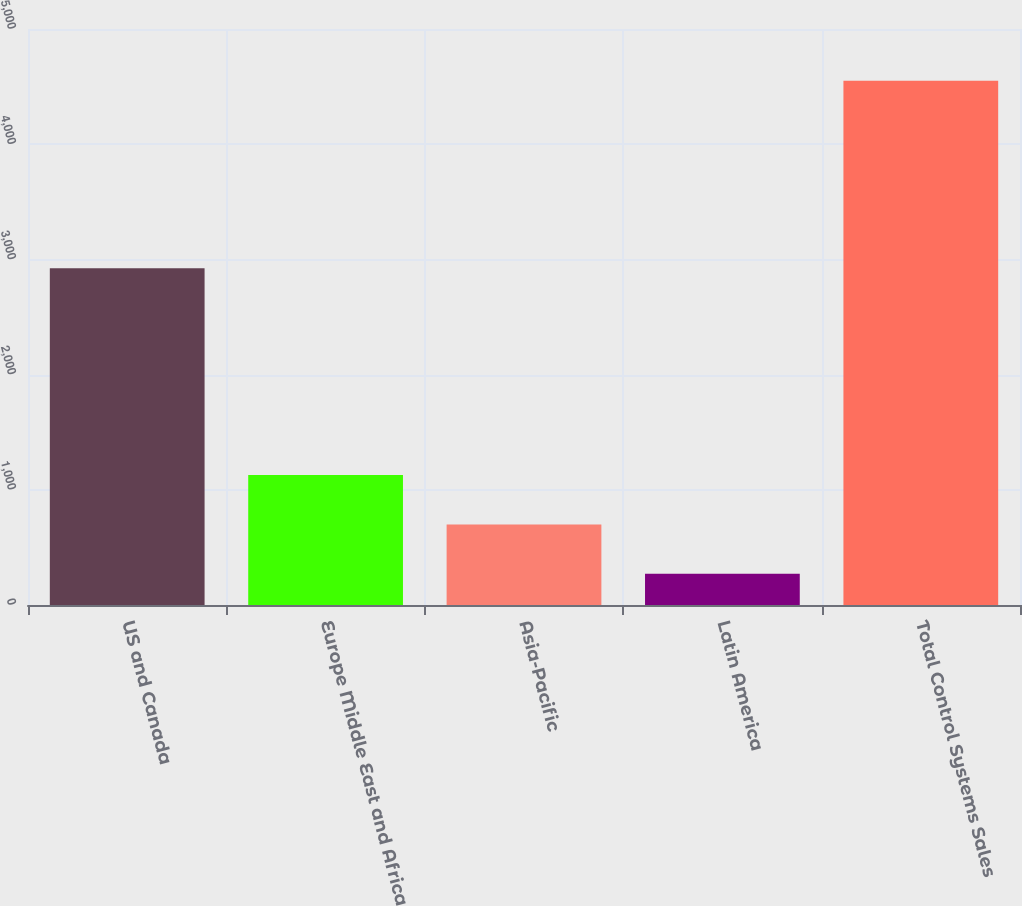Convert chart to OTSL. <chart><loc_0><loc_0><loc_500><loc_500><bar_chart><fcel>US and Canada<fcel>Europe Middle East and Africa<fcel>Asia-Pacific<fcel>Latin America<fcel>Total Control Systems Sales<nl><fcel>2923.6<fcel>1127.46<fcel>699.48<fcel>271.5<fcel>4551.3<nl></chart> 